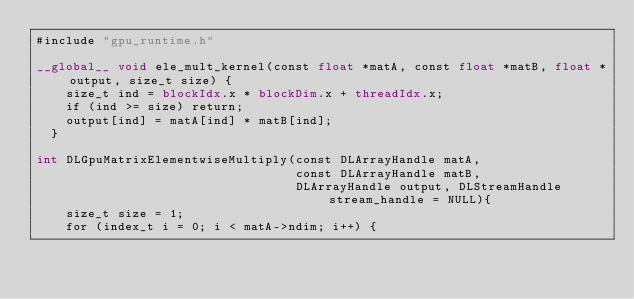<code> <loc_0><loc_0><loc_500><loc_500><_Cuda_>#include "gpu_runtime.h"

__global__ void ele_mult_kernel(const float *matA, const float *matB, float *output, size_t size) {
    size_t ind = blockIdx.x * blockDim.x + threadIdx.x;
    if (ind >= size) return;
    output[ind] = matA[ind] * matB[ind];
  }
  
int DLGpuMatrixElementwiseMultiply(const DLArrayHandle matA,
                                   const DLArrayHandle matB,
                                   DLArrayHandle output, DLStreamHandle stream_handle = NULL){
    size_t size = 1;
    for (index_t i = 0; i < matA->ndim; i++) {</code> 